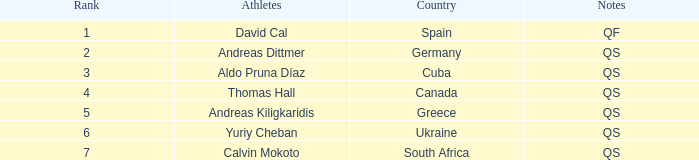Could you parse the entire table as a dict? {'header': ['Rank', 'Athletes', 'Country', 'Notes'], 'rows': [['1', 'David Cal', 'Spain', 'QF'], ['2', 'Andreas Dittmer', 'Germany', 'QS'], ['3', 'Aldo Pruna Díaz', 'Cuba', 'QS'], ['4', 'Thomas Hall', 'Canada', 'QS'], ['5', 'Andreas Kiligkaridis', 'Greece', 'QS'], ['6', 'Yuriy Cheban', 'Ukraine', 'QS'], ['7', 'Calvin Mokoto', 'South Africa', 'QS']]} What are the notes for the athlete from Spain? QF. 